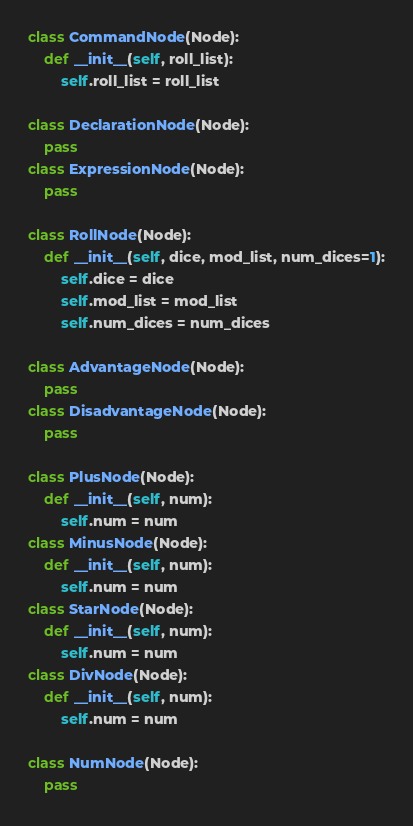Convert code to text. <code><loc_0><loc_0><loc_500><loc_500><_Python_>class CommandNode(Node):
    def __init__(self, roll_list):
        self.roll_list = roll_list

class DeclarationNode(Node):
    pass
class ExpressionNode(Node):
    pass

class RollNode(Node):
    def __init__(self, dice, mod_list, num_dices=1):
        self.dice = dice
        self.mod_list = mod_list
        self.num_dices = num_dices

class AdvantageNode(Node):
    pass
class DisadvantageNode(Node):
    pass

class PlusNode(Node):
    def __init__(self, num):
        self.num = num
class MinusNode(Node):
    def __init__(self, num):
        self.num = num
class StarNode(Node):
    def __init__(self, num):
        self.num = num
class DivNode(Node):
    def __init__(self, num):
        self.num = num

class NumNode(Node):
    pass</code> 